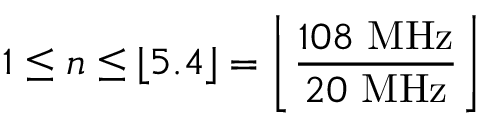Convert formula to latex. <formula><loc_0><loc_0><loc_500><loc_500>1 \leq n \leq \lfloor 5 . 4 \rfloor = \left \lfloor { \frac { 1 0 8 \ M H z } { 2 0 \ M H z } } \right \rfloor</formula> 